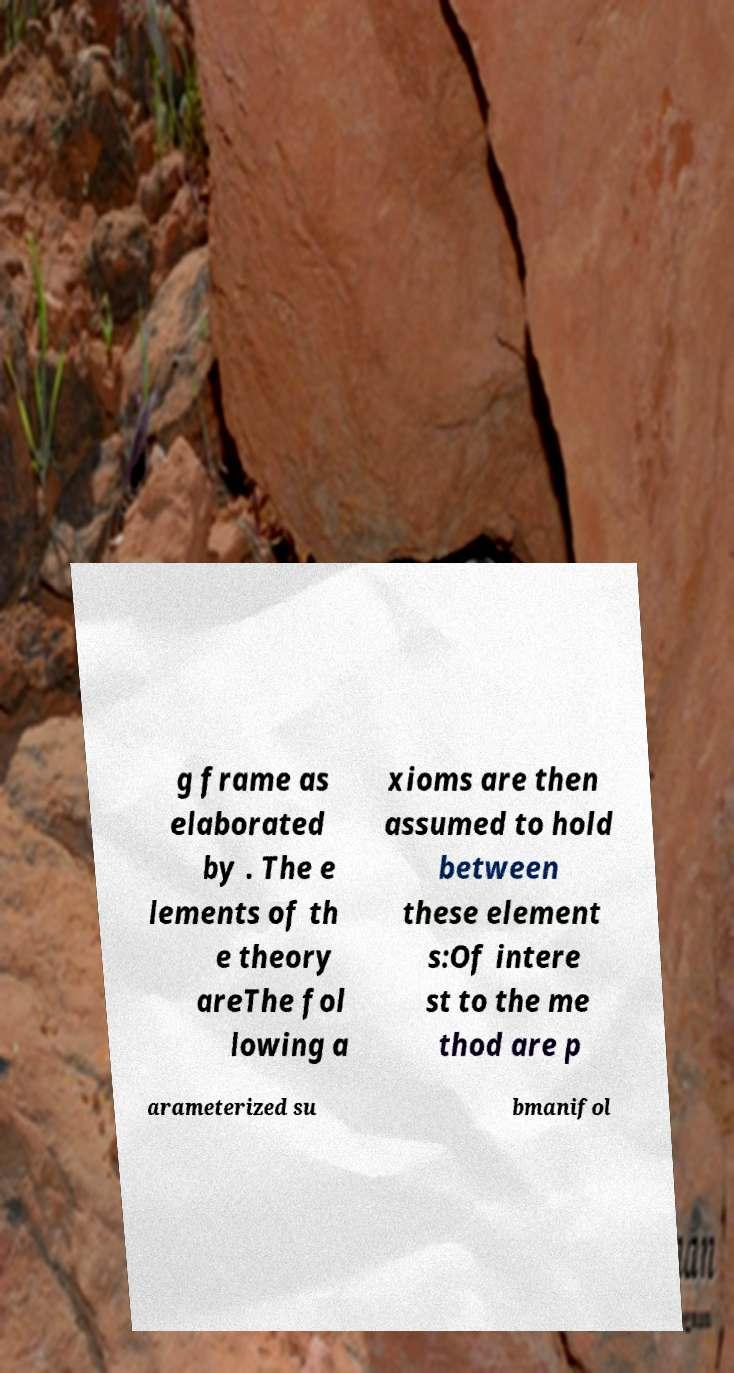For documentation purposes, I need the text within this image transcribed. Could you provide that? g frame as elaborated by . The e lements of th e theory areThe fol lowing a xioms are then assumed to hold between these element s:Of intere st to the me thod are p arameterized su bmanifol 